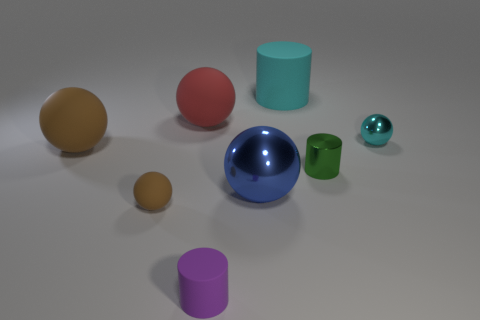Are there any cyan matte things that have the same shape as the purple rubber object?
Make the answer very short. Yes. What is the size of the cylinder that is behind the red rubber thing?
Make the answer very short. Large. What is the size of the blue shiny ball?
Your answer should be compact. Large. How many cylinders are either metal objects or large cyan objects?
Your answer should be compact. 2. What is the size of the cyan cylinder that is made of the same material as the tiny purple cylinder?
Make the answer very short. Large. How many big spheres are the same color as the small rubber sphere?
Your answer should be compact. 1. Are there any large rubber balls behind the large brown matte object?
Offer a very short reply. Yes. There is a small cyan object; is its shape the same as the large shiny thing that is on the left side of the cyan shiny thing?
Your answer should be very brief. Yes. What number of things are either tiny balls that are to the left of the tiny cyan sphere or yellow objects?
Your response must be concise. 1. What number of matte balls are to the left of the large red matte thing and behind the small brown object?
Your answer should be very brief. 1. 